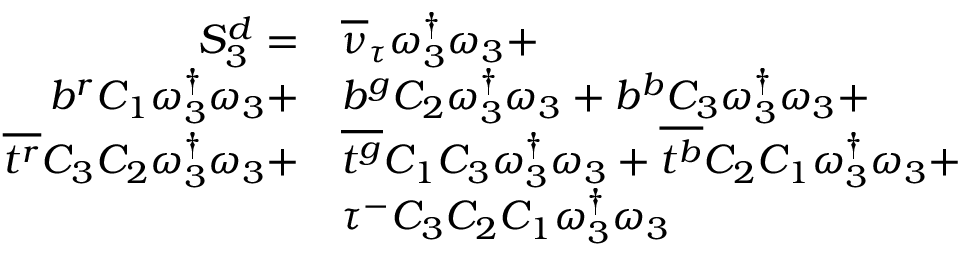<formula> <loc_0><loc_0><loc_500><loc_500>\begin{array} { r l } { S _ { 3 } ^ { d } = } & { { \overline { \nu } _ { \tau } } \omega _ { 3 } ^ { \dagger } \omega _ { 3 } + } \\ { { b } ^ { r } { C _ { 1 } } \omega _ { 3 } ^ { \dagger } \omega _ { 3 } + } & { { b } ^ { g } { C _ { 2 } } \omega _ { 3 } ^ { \dagger } \omega _ { 3 } + { b } ^ { b } { C _ { 3 } } \omega _ { 3 } ^ { \dagger } \omega _ { 3 } + } \\ { \overline { { t ^ { r } } } { C _ { 3 } } { C _ { 2 } } \omega _ { 3 } ^ { \dagger } \omega _ { 3 } + } & { \overline { { t ^ { g } } } { C _ { 1 } } { C _ { 3 } } \omega _ { 3 } ^ { \dagger } \omega _ { 3 } + \overline { { t ^ { b } } } { C _ { 2 } } { C _ { 1 } } \omega _ { 3 } ^ { \dagger } \omega _ { 3 } + } \\ & { \tau ^ { - } { C _ { 3 } } { C _ { 2 } } { C _ { 1 } } \omega _ { 3 } ^ { \dagger } \omega _ { 3 } } \end{array}</formula> 